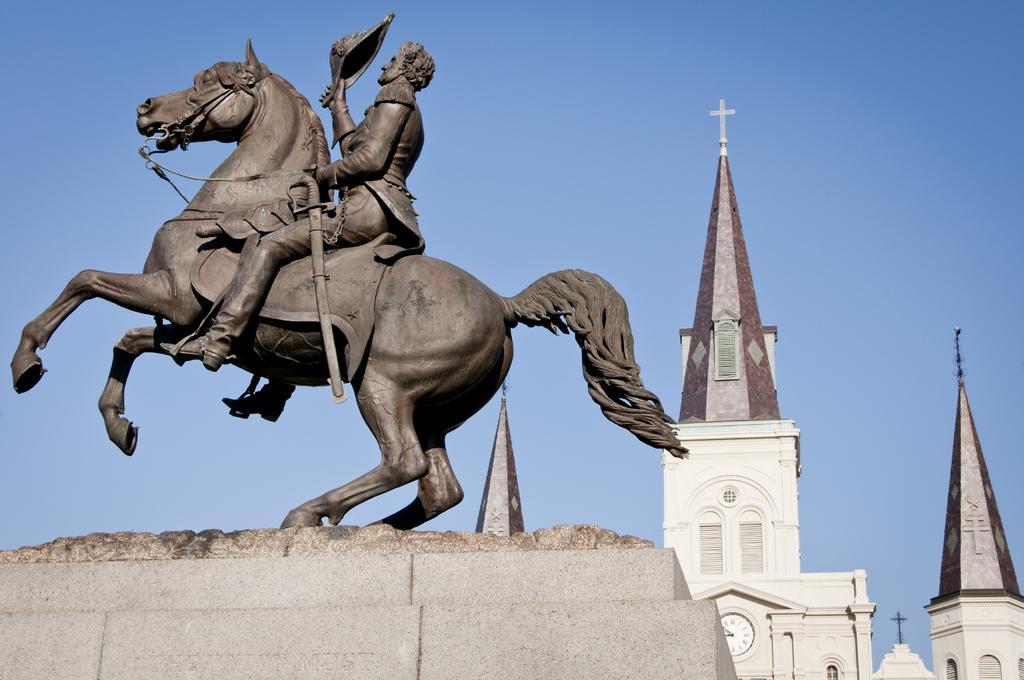Can you describe this image briefly? In this image there is a statue of a horse on which there is a man, on the left side. In the background it seems like a church. At the top there is the sky. There is a wall clock fixed in the middle of the wall. At the top of the church there is a cross symbol. 